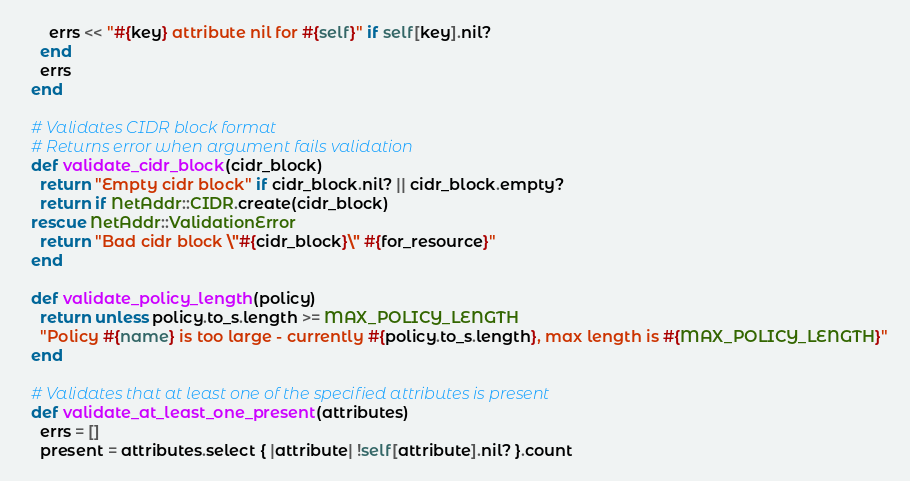Convert code to text. <code><loc_0><loc_0><loc_500><loc_500><_Ruby_>      errs << "#{key} attribute nil for #{self}" if self[key].nil?
    end
    errs
  end

  # Validates CIDR block format
  # Returns error when argument fails validation
  def validate_cidr_block(cidr_block)
    return "Empty cidr block" if cidr_block.nil? || cidr_block.empty?
    return if NetAddr::CIDR.create(cidr_block)
  rescue NetAddr::ValidationError
    return "Bad cidr block \"#{cidr_block}\" #{for_resource}"
  end

  def validate_policy_length(policy)
    return unless policy.to_s.length >= MAX_POLICY_LENGTH
    "Policy #{name} is too large - currently #{policy.to_s.length}, max length is #{MAX_POLICY_LENGTH}"
  end

  # Validates that at least one of the specified attributes is present
  def validate_at_least_one_present(attributes)
    errs = []
    present = attributes.select { |attribute| !self[attribute].nil? }.count</code> 